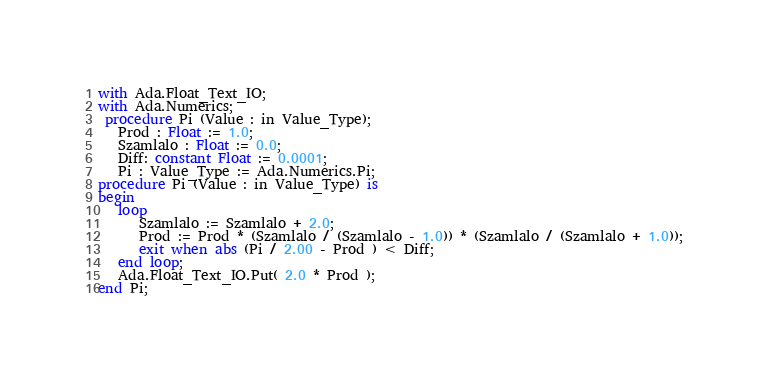<code> <loc_0><loc_0><loc_500><loc_500><_Ada_>with Ada.Float_Text_IO;
with Ada.Numerics;
 procedure Pi (Value : in Value_Type);
   Prod : Float := 1.0;
   Szamlalo : Float := 0.0;
   Diff: constant Float := 0.0001;
   Pi : Value_Type := Ada.Numerics.Pi;
procedure Pi (Value : in Value_Type) is
begin
   loop
      Szamlalo := Szamlalo + 2.0;
      Prod := Prod * (Szamlalo / (Szamlalo - 1.0)) * (Szamlalo / (Szamlalo + 1.0));
      exit when abs (Pi / 2.00 - Prod ) < Diff;
   end loop;
   Ada.Float_Text_IO.Put( 2.0 * Prod );
end Pi;
</code> 